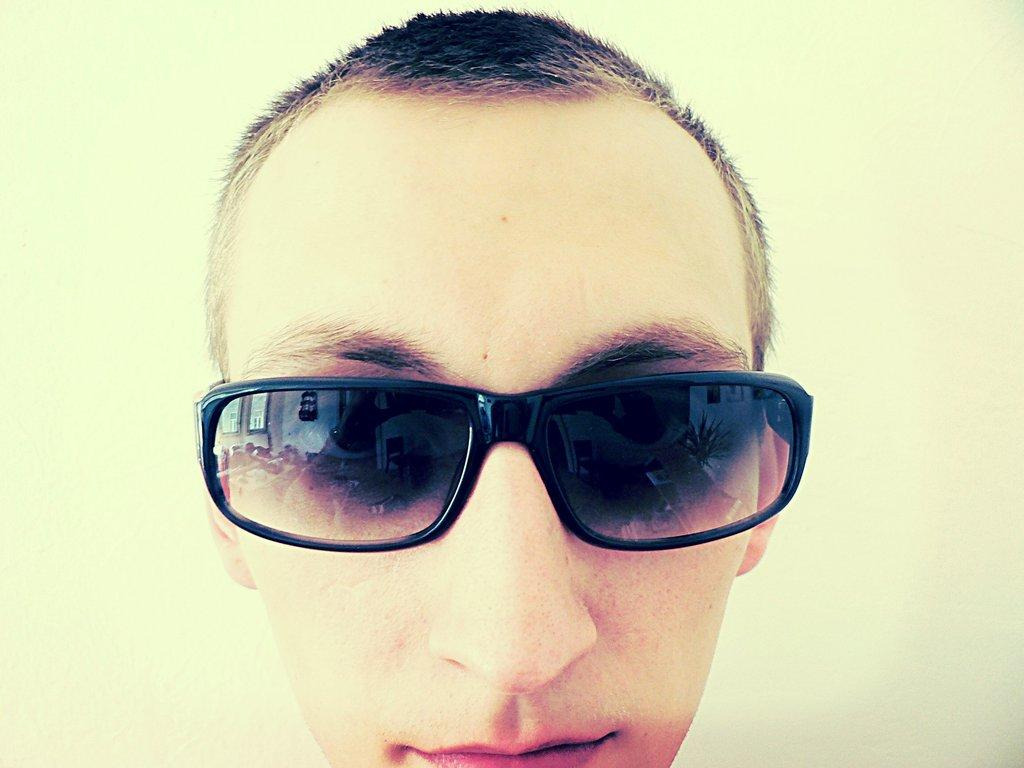Who or what is the main subject in the image? There is a person in the image. What accessory is the person wearing? The person is wearing glasses. What can be seen in the background of the image? There is a wall in the background of the image. How many houses can be seen in the alley behind the person in the image? There is no alley or houses present in the image; it only features a person and a wall in the background. 